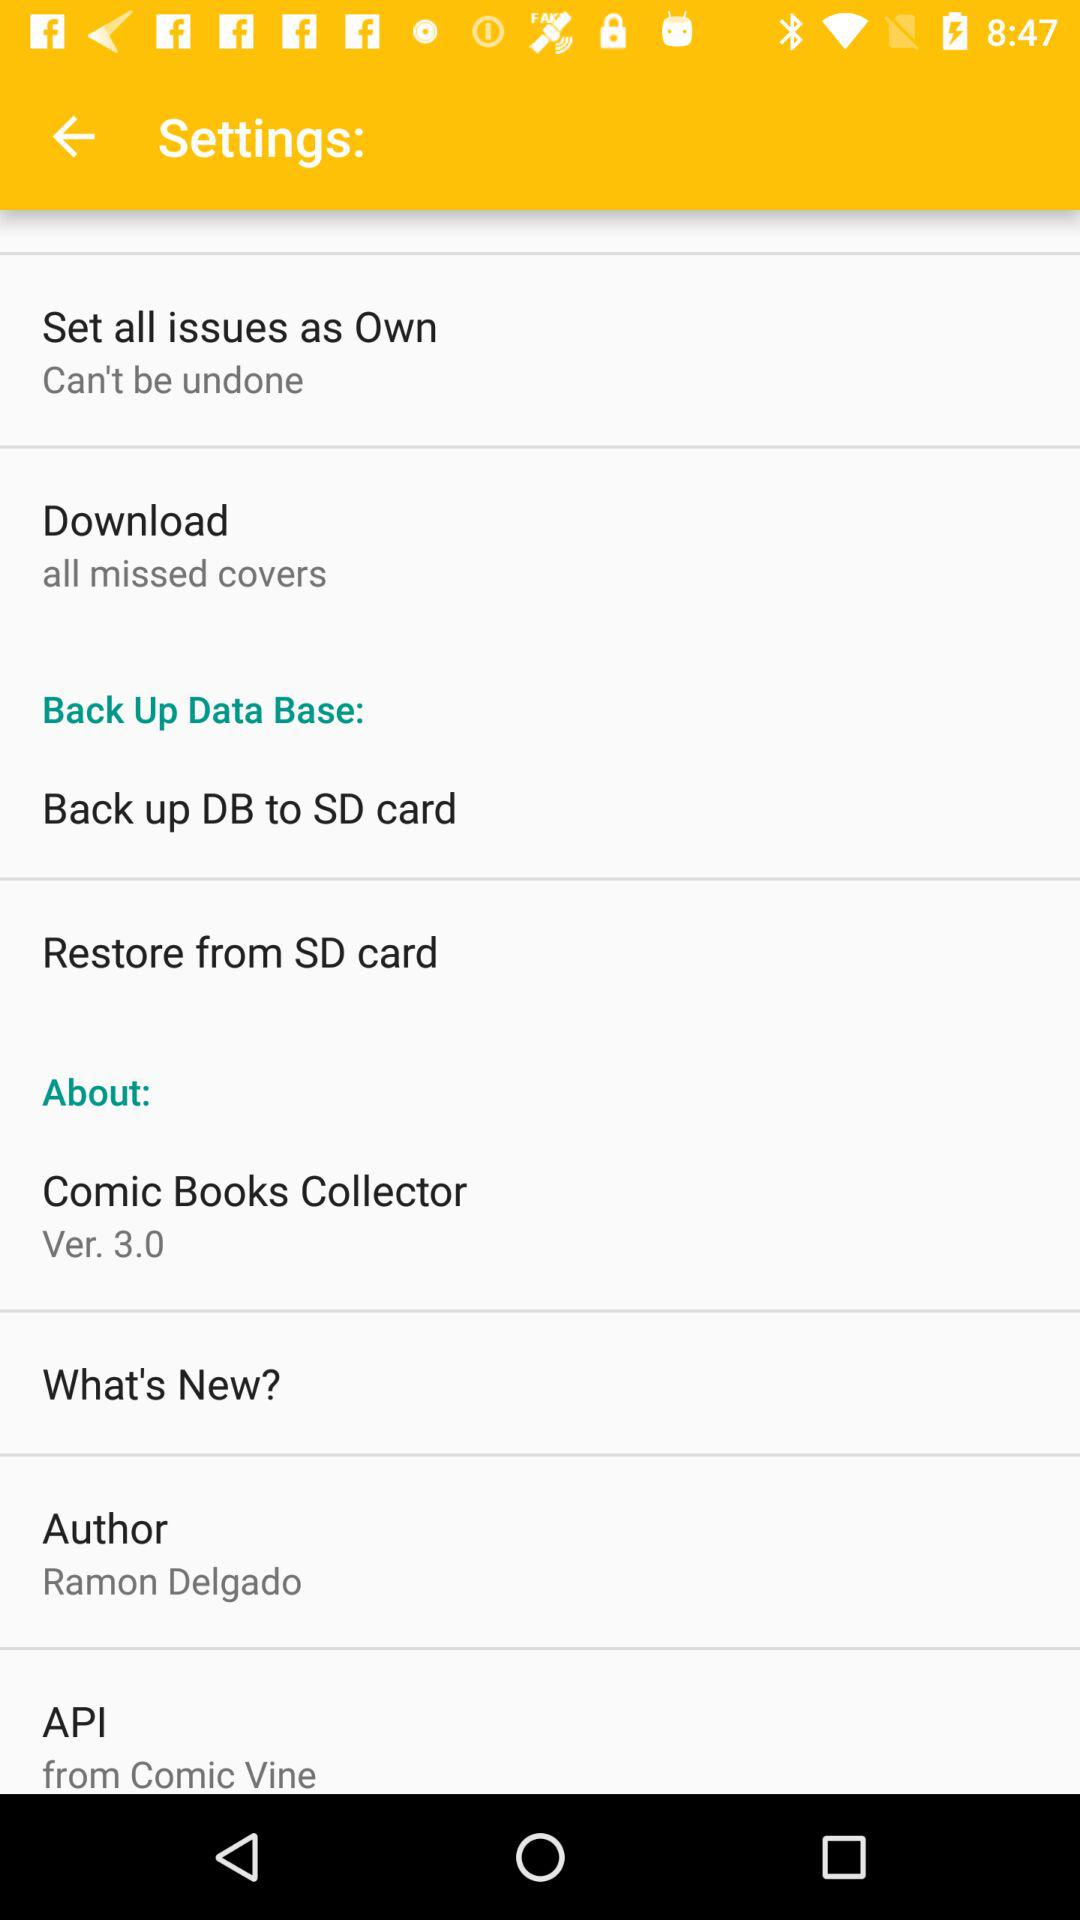Who is the author? The author is Ramon Delgado. 